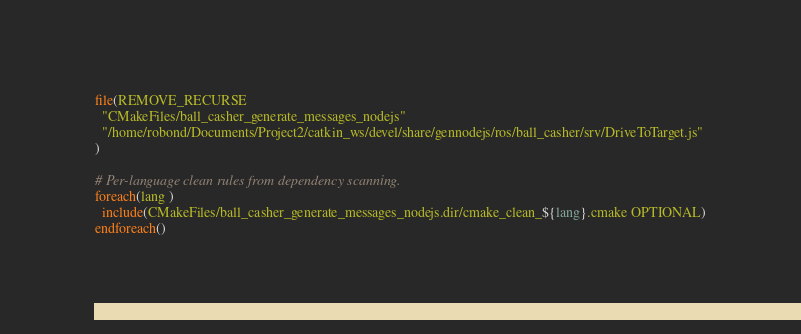Convert code to text. <code><loc_0><loc_0><loc_500><loc_500><_CMake_>file(REMOVE_RECURSE
  "CMakeFiles/ball_casher_generate_messages_nodejs"
  "/home/robond/Documents/Project2/catkin_ws/devel/share/gennodejs/ros/ball_casher/srv/DriveToTarget.js"
)

# Per-language clean rules from dependency scanning.
foreach(lang )
  include(CMakeFiles/ball_casher_generate_messages_nodejs.dir/cmake_clean_${lang}.cmake OPTIONAL)
endforeach()
</code> 